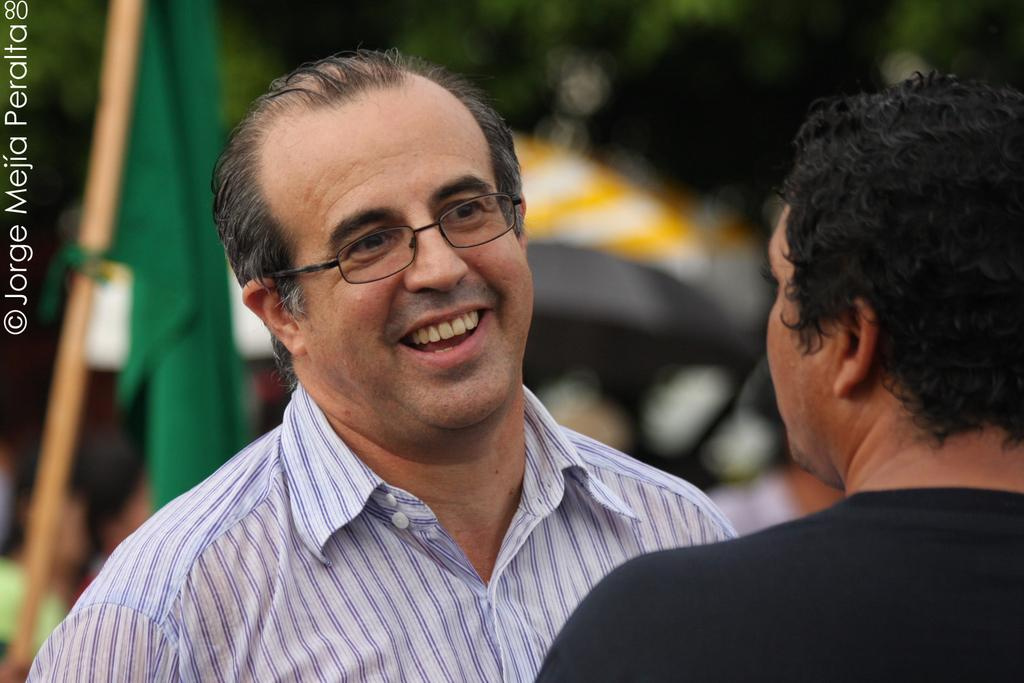How many people are in the image? There are two persons in the image. What can be observed about the background of the image? The background of the image is blurred. What structure is present in the image? There is a flag pole in the image. Where is the text located in the image? The text is on the left side of the image. Can you hear the goat singing a song in the image? There is no goat or song present in the image. How does the earthquake affect the flag pole in the image? There is no earthquake depicted in the image, so its effect on the flag pole cannot be determined. 